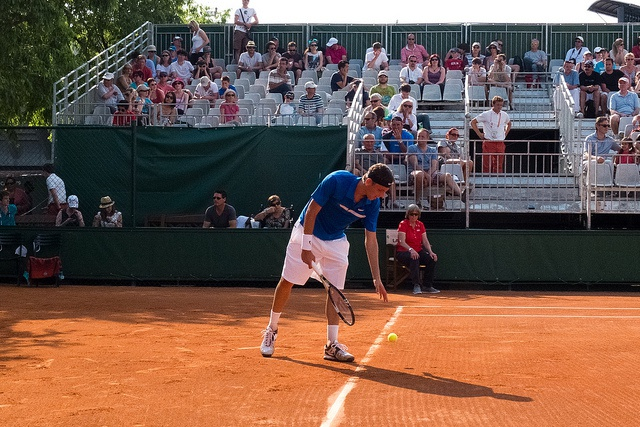Describe the objects in this image and their specific colors. I can see people in black, gray, darkgray, and maroon tones, people in black, lightpink, navy, and maroon tones, chair in black, darkgray, and gray tones, people in black, lavender, gray, and darkgray tones, and bench in black tones in this image. 